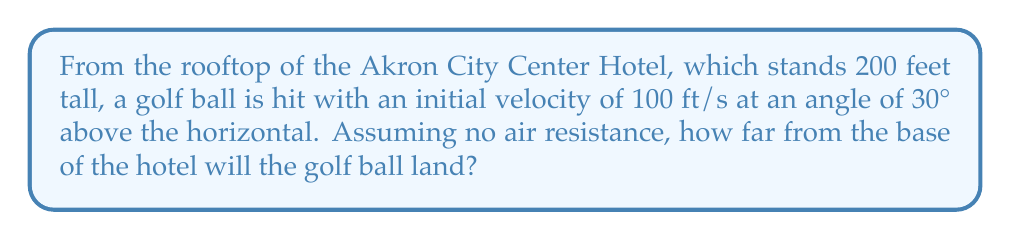What is the answer to this math problem? Let's approach this step-by-step using the equations of projectile motion:

1) First, we need to break down the initial velocity into its horizontal and vertical components:

   $v_{0x} = v_0 \cos \theta = 100 \cdot \cos 30° = 86.6$ ft/s
   $v_{0y} = v_0 \sin \theta = 100 \cdot \sin 30° = 50$ ft/s

2) The time of flight can be calculated using the equation:

   $$y = y_0 + v_{0y}t - \frac{1}{2}gt^2$$

   Where $y = 0$ (ground level), $y_0 = 200$ ft (initial height), $g = 32.2$ ft/s² (acceleration due to gravity)

3) Substituting these values:

   $$0 = 200 + 50t - 16.1t^2$$

4) This quadratic equation can be solved for t:

   $$16.1t^2 - 50t - 200 = 0$$

   Using the quadratic formula, we get $t \approx 5.67$ seconds

5) Now that we know the time of flight, we can calculate the horizontal distance:

   $$x = v_{0x}t = 86.6 \cdot 5.67 \approx 491$ ft

Therefore, the golf ball will land approximately 491 feet from the base of the hotel.
Answer: 491 feet 